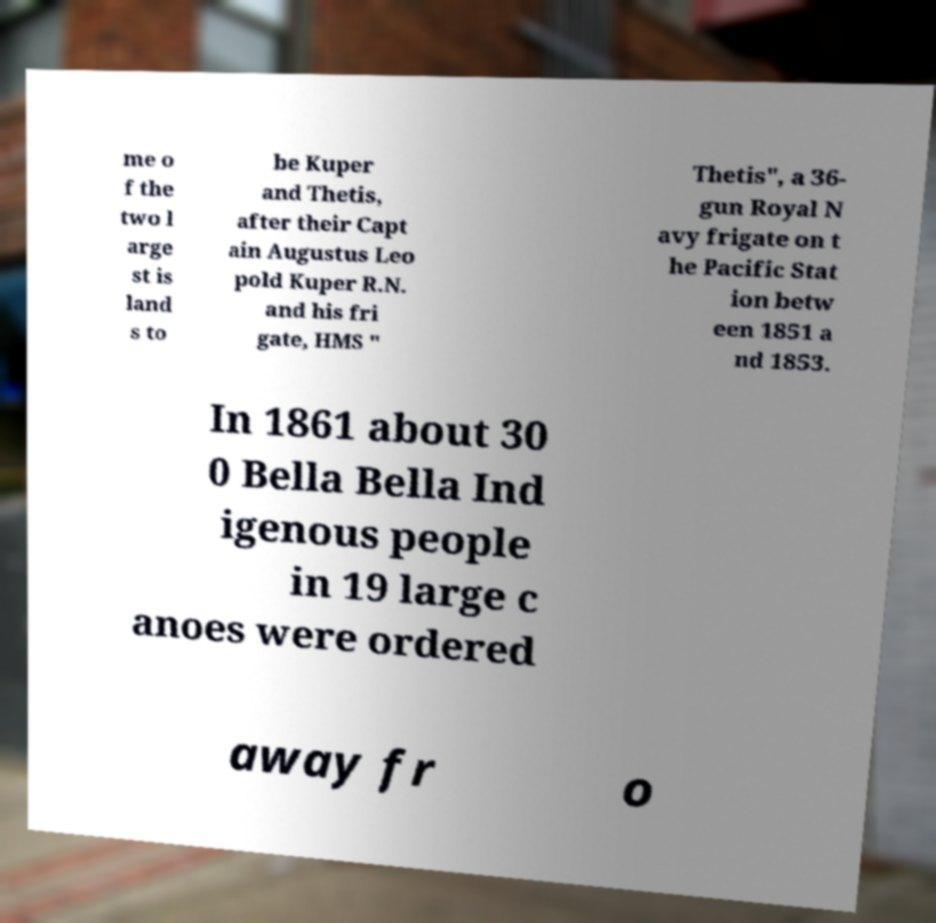Can you accurately transcribe the text from the provided image for me? me o f the two l arge st is land s to be Kuper and Thetis, after their Capt ain Augustus Leo pold Kuper R.N. and his fri gate, HMS " Thetis", a 36- gun Royal N avy frigate on t he Pacific Stat ion betw een 1851 a nd 1853. In 1861 about 30 0 Bella Bella Ind igenous people in 19 large c anoes were ordered away fr o 